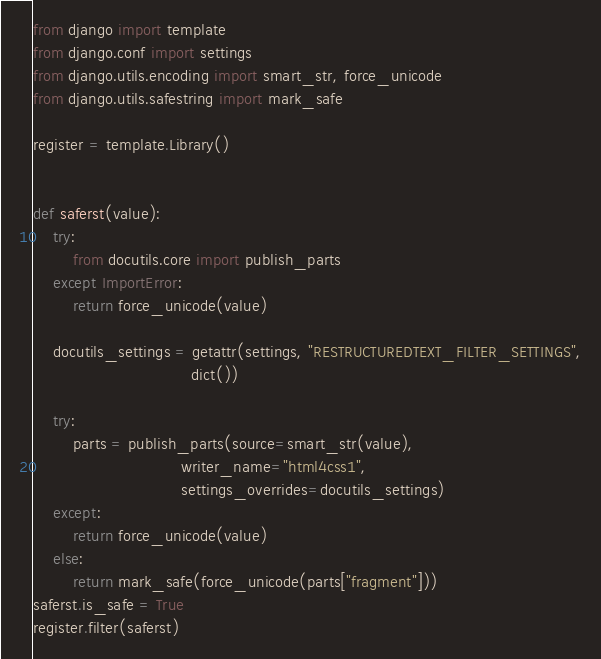<code> <loc_0><loc_0><loc_500><loc_500><_Python_>from django import template
from django.conf import settings
from django.utils.encoding import smart_str, force_unicode
from django.utils.safestring import mark_safe

register = template.Library()


def saferst(value):
    try:
        from docutils.core import publish_parts
    except ImportError:
        return force_unicode(value)

    docutils_settings = getattr(settings, "RESTRUCTUREDTEXT_FILTER_SETTINGS",
                                dict())
    
    try:
        parts = publish_parts(source=smart_str(value),
                              writer_name="html4css1",
                              settings_overrides=docutils_settings)
    except:
        return force_unicode(value)
    else:
        return mark_safe(force_unicode(parts["fragment"]))
saferst.is_safe = True
register.filter(saferst)

</code> 